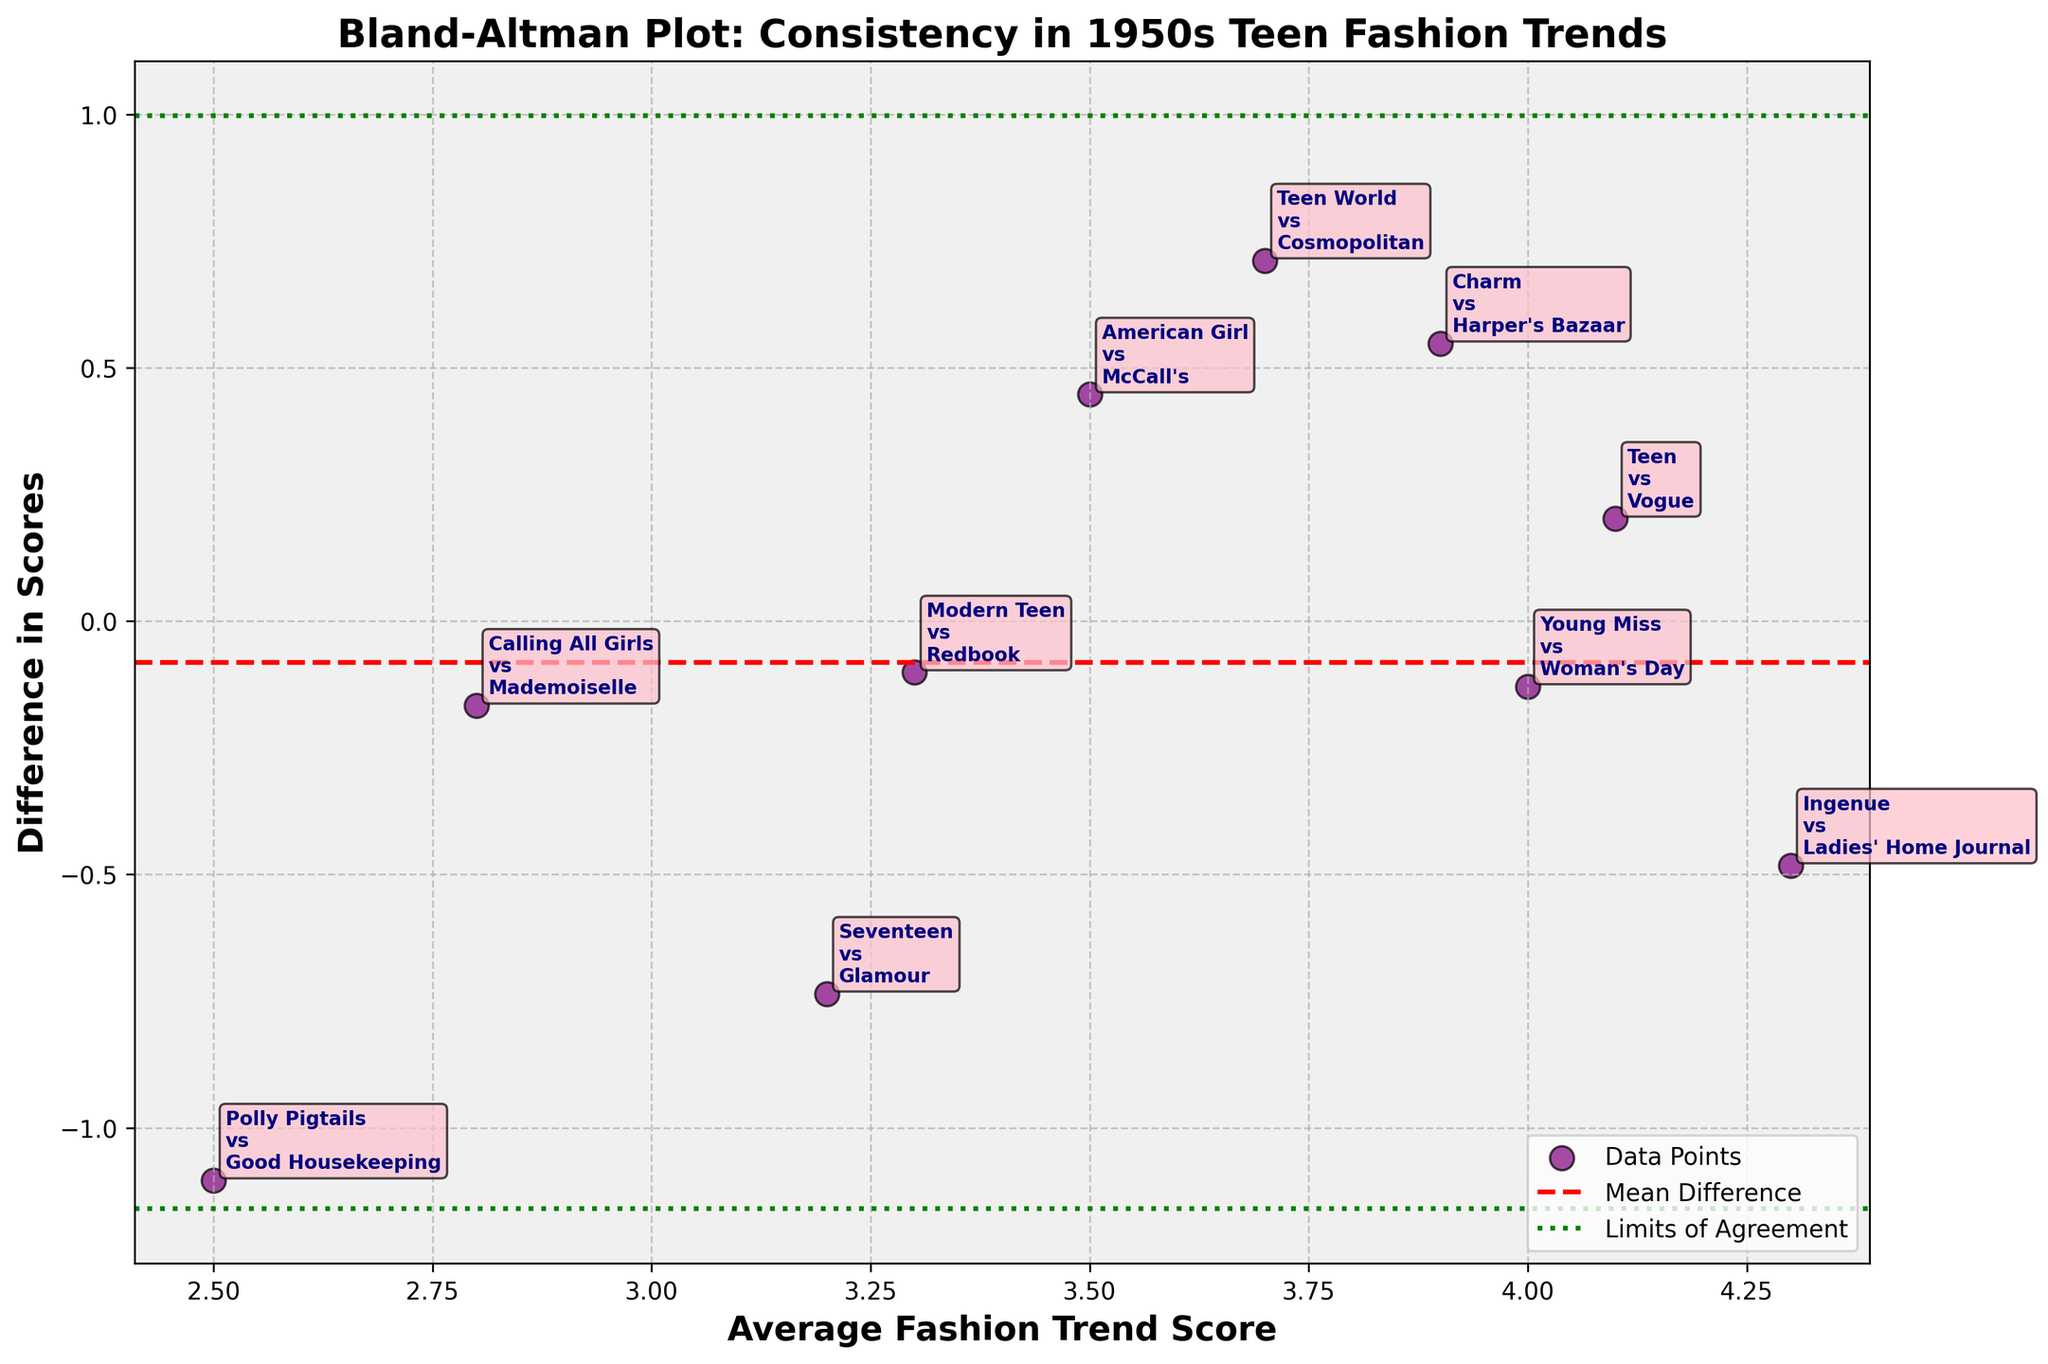What is the title of the plot? The title of the plot is usually found at the top and provides a summary of what the figure is about. In this plot, the title is formatted in a larger and bold font.
Answer: Bland-Altman Plot: Consistency in 1950s Teen Fashion Trends How many data points are represented in the plot? To find the number of data points, you can count the scatter points on the plot. Each represents a comparison between two magazines.
Answer: 10 Which magazines are compared at the highest average fashion trend score? By looking at the annotated scatter points, identify the data point with the highest position on the x-axis (Average Fashion Trend Score).
Answer: Ingenue vs Ladies' Home Journal What color are the scatter points representing the data points? The color of the scatter points can be identified by visual inspection of the plot. They are distinctly colored to stand out against the background.
Answer: Purple What's the range of the limits of agreement indicated in the plot? The limits of agreement are marked by two green dashed lines, and their values can be read off the y-axis where these lines intercept.
Answer: Approximately -1.0 to 1.0 Which magazine pair shows the highest positive difference in scores? Identify the data point with the highest position on the y-axis. The annotation for this point will give the magazine pair.
Answer: Teen vs Vogue Are any magazine pairs showing a negative difference in their scores? Check if any of the scatter points are below the horizontal line at 0 on the y-axis, indicating negative differences.
Answer: Yes Does the mean difference lie above or below the zero line on the y-axis? The mean difference is marked by a red dashed line. Compare its position relative to the zero line on the y-axis.
Answer: Above How consistent are the fashion trends reported by Seventeen and Glamour compared to those by Polly Pigtails and Good Housekeeping? By comparing the y-axis positions of the annotated scatter points for these magazine pairs, you can assess the consistency through their difference values. Seventeen vs. Glamour should be near -0.5, and Polly Pigtails vs. Good Housekeeping should be around -0.3, showing less consistency for Seventeen vs. Glamour due to a larger absolute difference.
Answer: Less consistent 